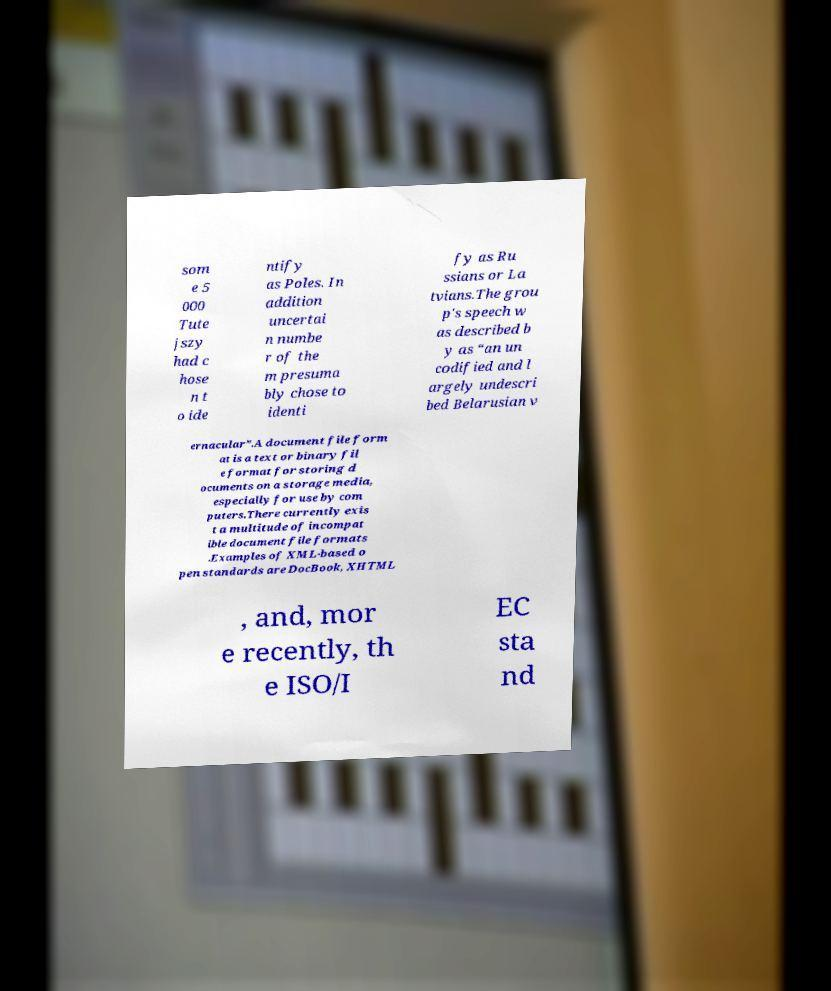There's text embedded in this image that I need extracted. Can you transcribe it verbatim? som e 5 000 Tute jszy had c hose n t o ide ntify as Poles. In addition uncertai n numbe r of the m presuma bly chose to identi fy as Ru ssians or La tvians.The grou p's speech w as described b y as “an un codified and l argely undescri bed Belarusian v ernacular”.A document file form at is a text or binary fil e format for storing d ocuments on a storage media, especially for use by com puters.There currently exis t a multitude of incompat ible document file formats .Examples of XML-based o pen standards are DocBook, XHTML , and, mor e recently, th e ISO/I EC sta nd 